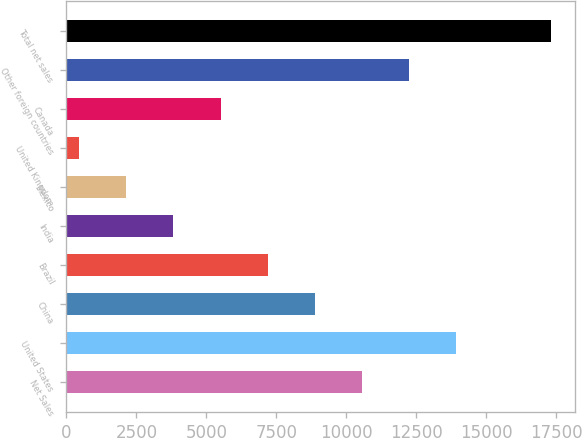Convert chart. <chart><loc_0><loc_0><loc_500><loc_500><bar_chart><fcel>Net Sales<fcel>United States<fcel>China<fcel>Brazil<fcel>India<fcel>Mexico<fcel>United Kingdom<fcel>Canada<fcel>Other foreign countries<fcel>Total net sales<nl><fcel>10561.8<fcel>13931.4<fcel>8877<fcel>7192.2<fcel>3822.6<fcel>2137.8<fcel>453<fcel>5507.4<fcel>12246.6<fcel>17301<nl></chart> 